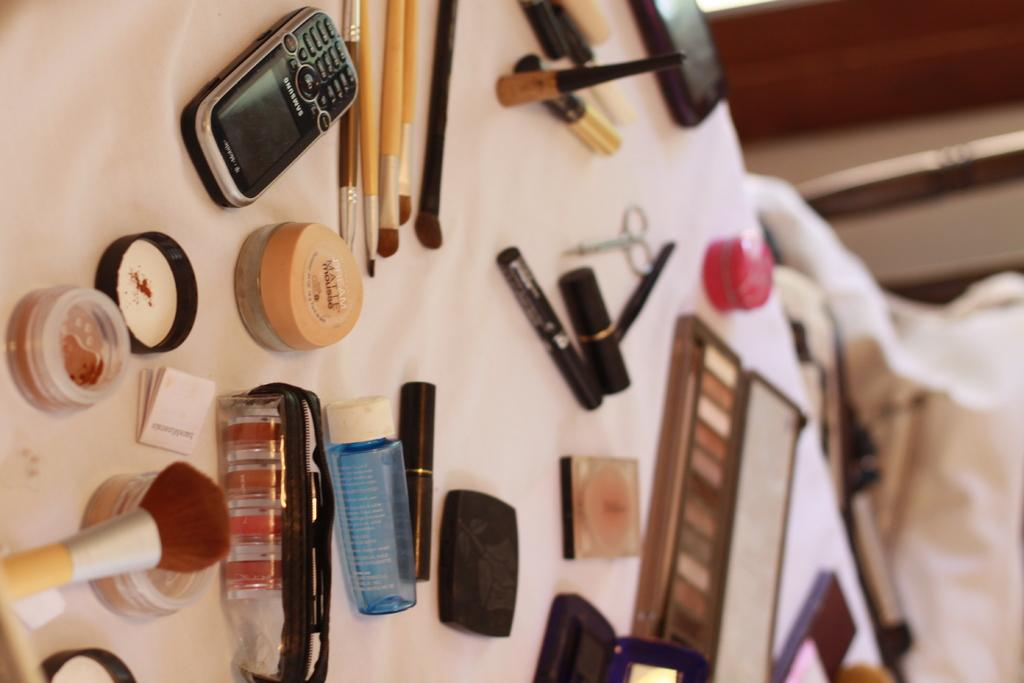<image>
Present a compact description of the photo's key features. A black Samsung phone sits on a table next to cosmetics. 